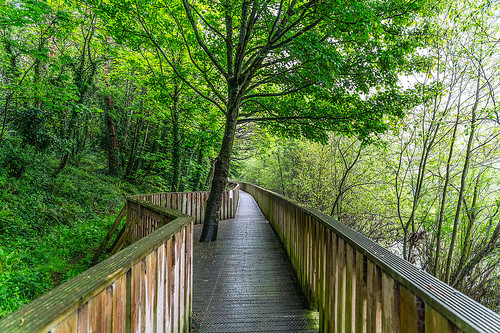<image>
Is the tree in the sidewalk? Yes. The tree is contained within or inside the sidewalk, showing a containment relationship. 